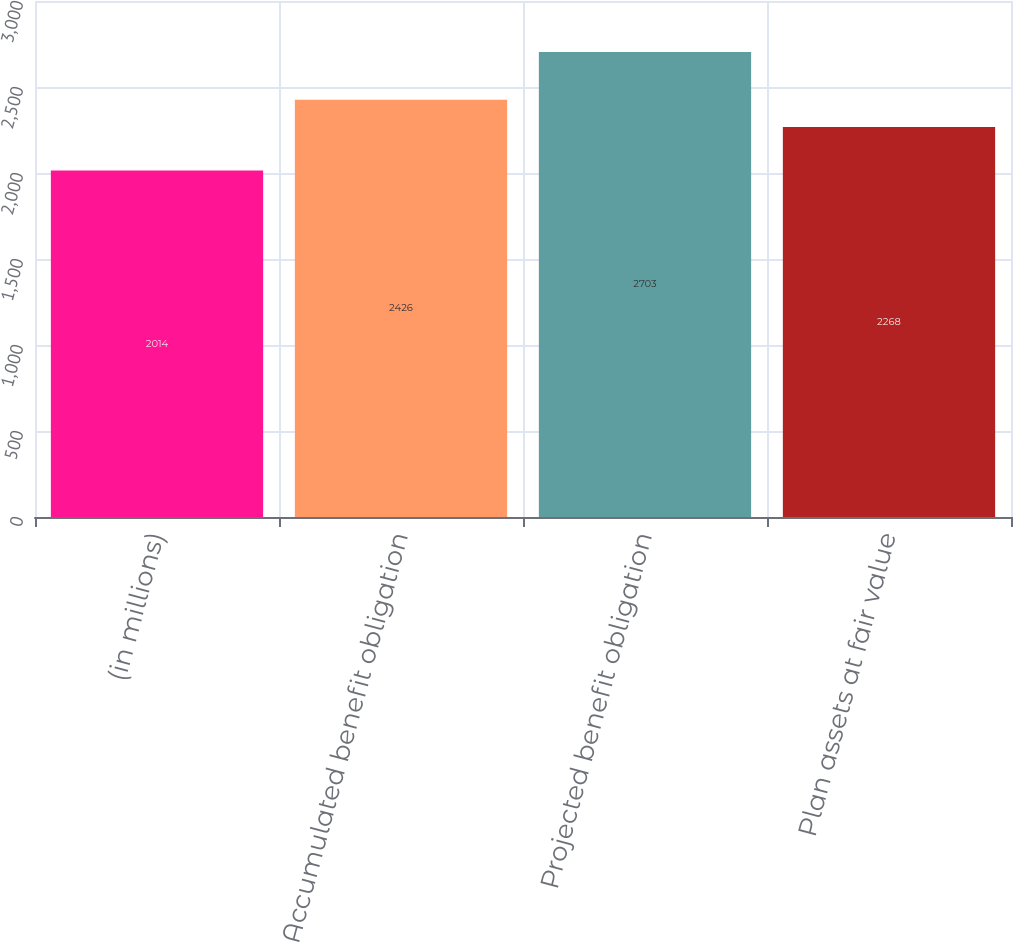<chart> <loc_0><loc_0><loc_500><loc_500><bar_chart><fcel>(in millions)<fcel>Accumulated benefit obligation<fcel>Projected benefit obligation<fcel>Plan assets at fair value<nl><fcel>2014<fcel>2426<fcel>2703<fcel>2268<nl></chart> 